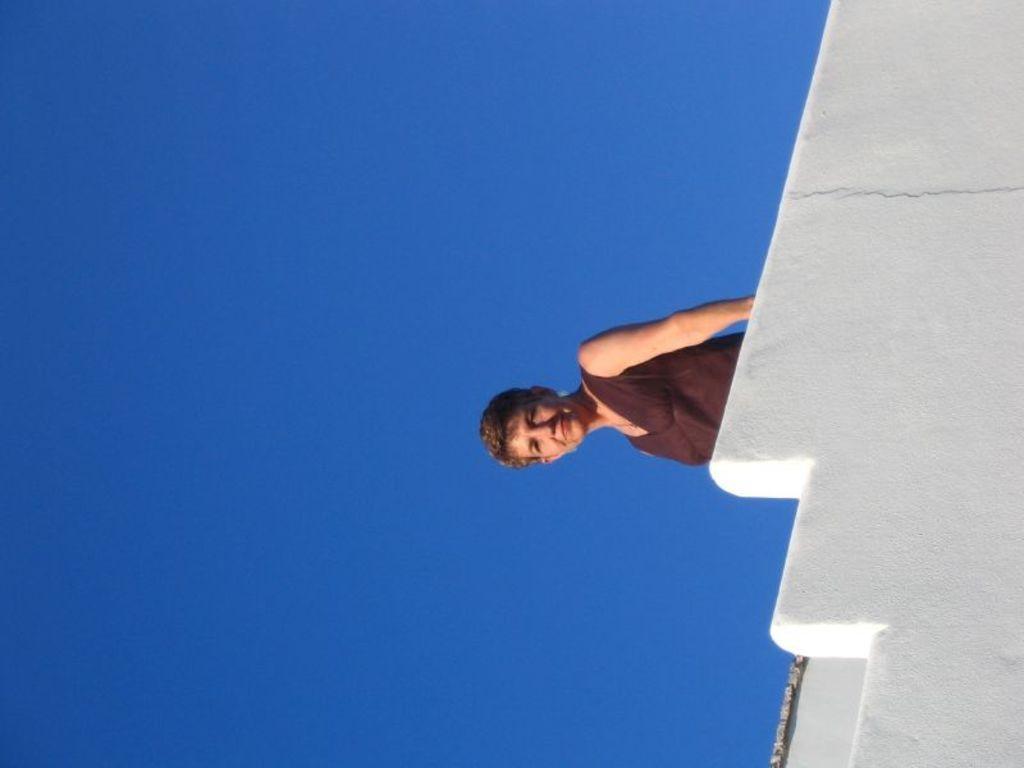How would you summarize this image in a sentence or two? The woman in the middle of the picture wearing brown dress is stunning. She is smiling. Beside her, we see a white wall. In the background, we see the sky, which is blue in color. 